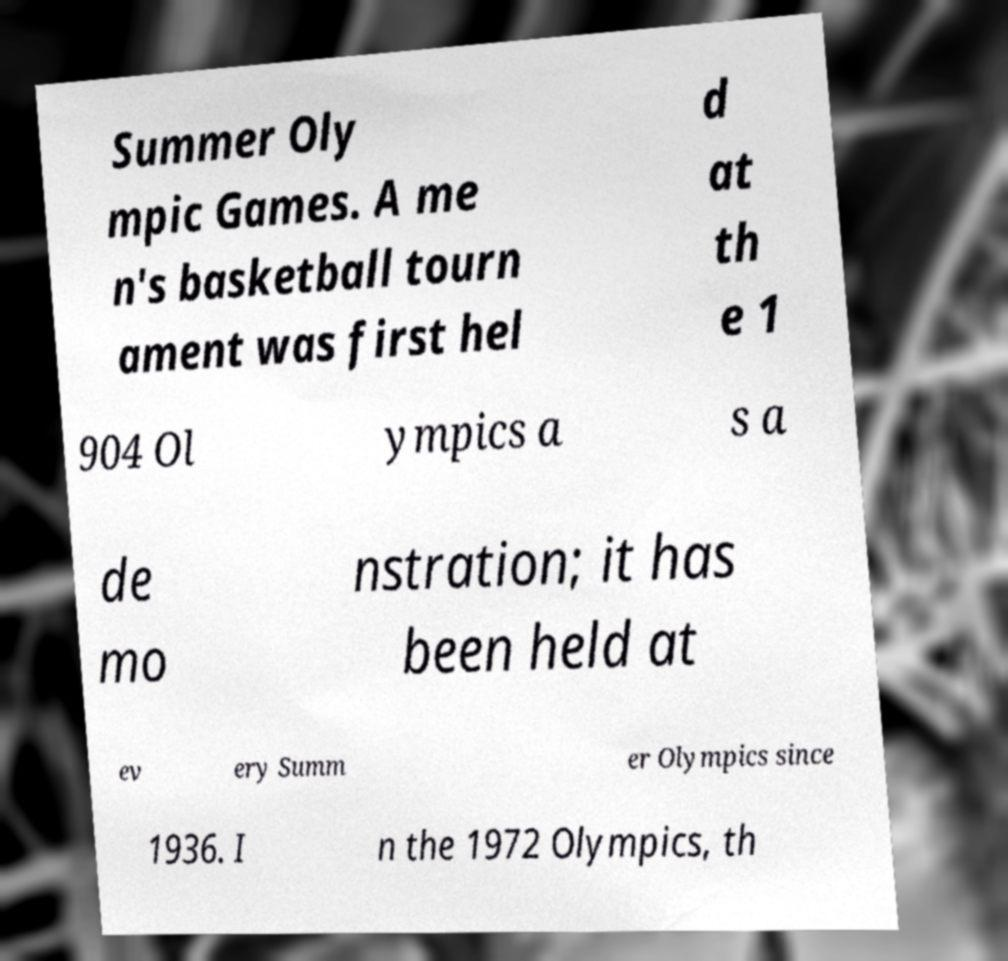Could you extract and type out the text from this image? Summer Oly mpic Games. A me n's basketball tourn ament was first hel d at th e 1 904 Ol ympics a s a de mo nstration; it has been held at ev ery Summ er Olympics since 1936. I n the 1972 Olympics, th 